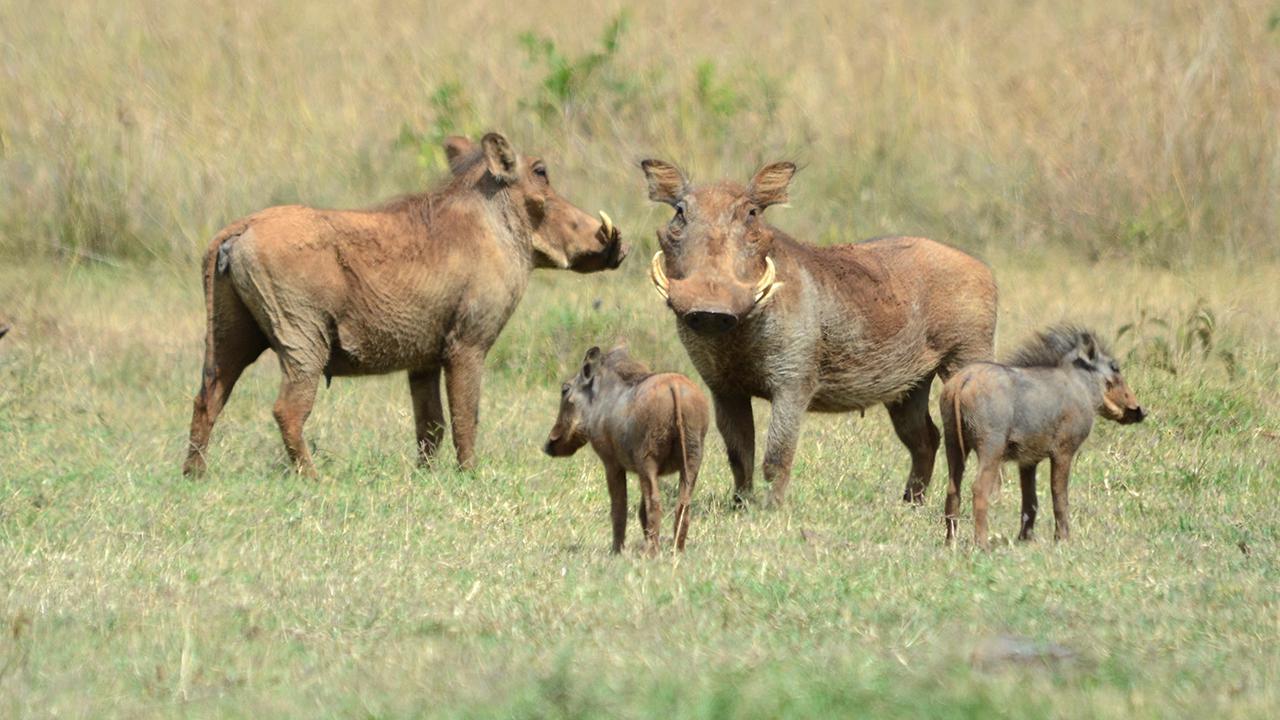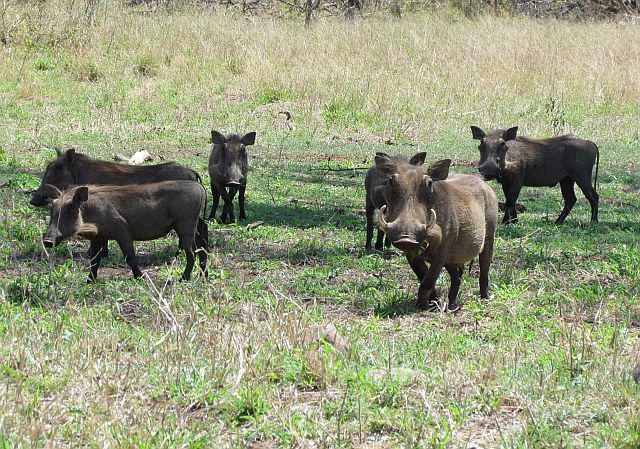The first image is the image on the left, the second image is the image on the right. Analyze the images presented: Is the assertion "There are at least five black animals in the image on the right." valid? Answer yes or no. Yes. The first image is the image on the left, the second image is the image on the right. Evaluate the accuracy of this statement regarding the images: "In one of the images there is a group of warthogs standing near water.". Is it true? Answer yes or no. No. 